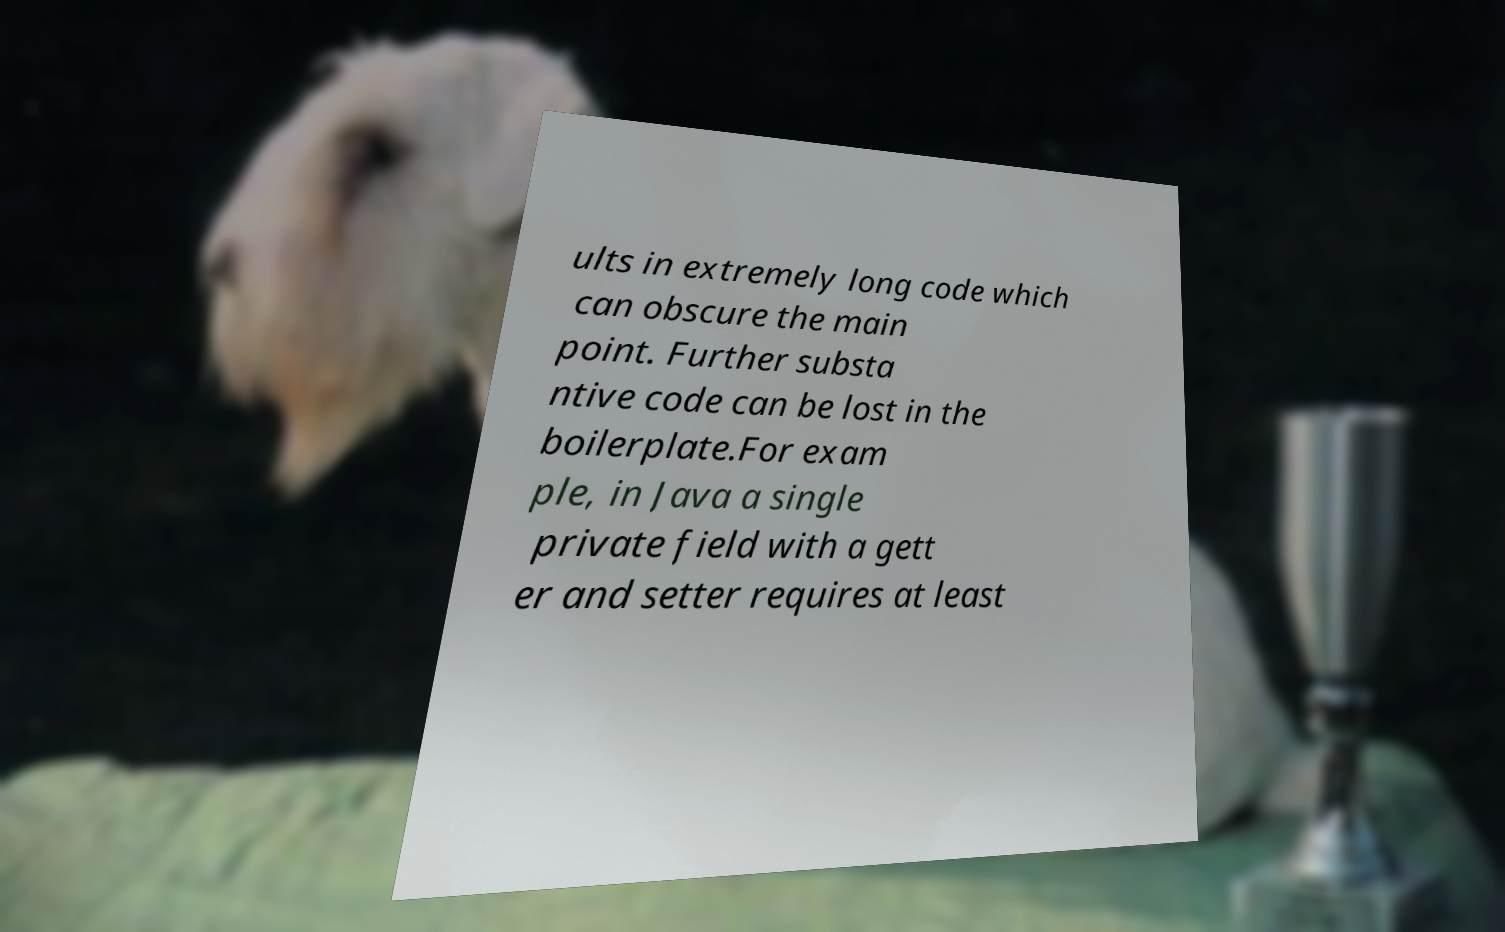I need the written content from this picture converted into text. Can you do that? ults in extremely long code which can obscure the main point. Further substa ntive code can be lost in the boilerplate.For exam ple, in Java a single private field with a gett er and setter requires at least 